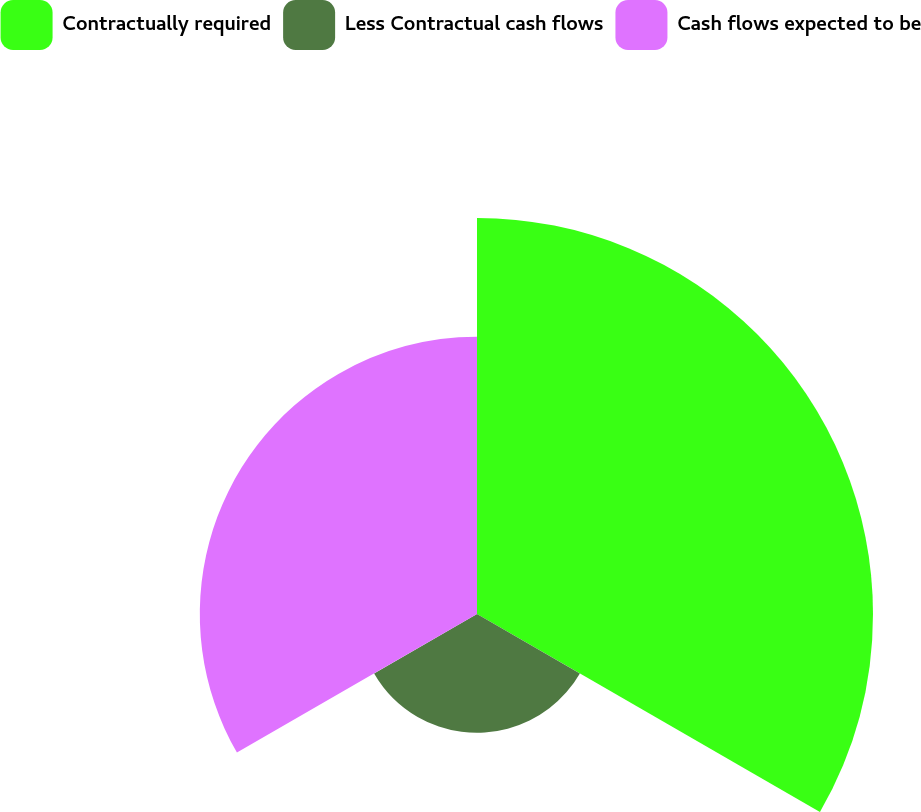<chart> <loc_0><loc_0><loc_500><loc_500><pie_chart><fcel>Contractually required<fcel>Less Contractual cash flows<fcel>Cash flows expected to be<nl><fcel>50.0%<fcel>15.0%<fcel>35.0%<nl></chart> 